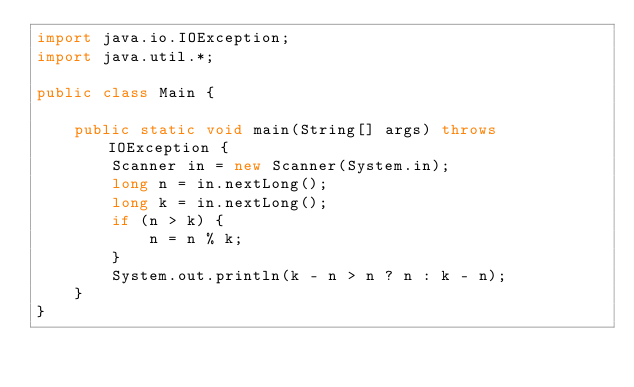<code> <loc_0><loc_0><loc_500><loc_500><_Java_>import java.io.IOException;
import java.util.*;

public class Main {

    public static void main(String[] args) throws IOException {
        Scanner in = new Scanner(System.in);
        long n = in.nextLong();
        long k = in.nextLong();
        if (n > k) {
            n = n % k;
        }
        System.out.println(k - n > n ? n : k - n);
    }
}</code> 